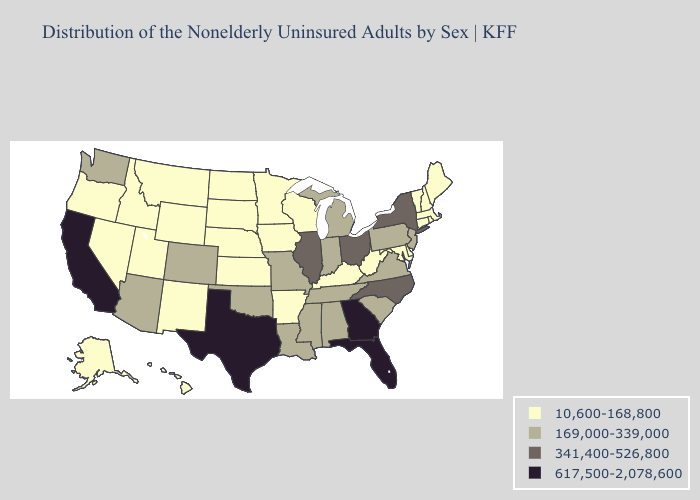Does Missouri have a higher value than Massachusetts?
Write a very short answer. Yes. What is the lowest value in the South?
Keep it brief. 10,600-168,800. Does Delaware have the lowest value in the South?
Write a very short answer. Yes. Does Illinois have the lowest value in the MidWest?
Concise answer only. No. What is the lowest value in the MidWest?
Be succinct. 10,600-168,800. Name the states that have a value in the range 169,000-339,000?
Quick response, please. Alabama, Arizona, Colorado, Indiana, Louisiana, Michigan, Mississippi, Missouri, New Jersey, Oklahoma, Pennsylvania, South Carolina, Tennessee, Virginia, Washington. Does Delaware have the lowest value in the South?
Write a very short answer. Yes. What is the highest value in states that border Tennessee?
Concise answer only. 617,500-2,078,600. What is the highest value in the MidWest ?
Concise answer only. 341,400-526,800. Does Montana have the same value as California?
Concise answer only. No. What is the value of Virginia?
Write a very short answer. 169,000-339,000. Does the first symbol in the legend represent the smallest category?
Be succinct. Yes. What is the highest value in the USA?
Short answer required. 617,500-2,078,600. Does Mississippi have the same value as Georgia?
Write a very short answer. No. What is the value of Colorado?
Short answer required. 169,000-339,000. 